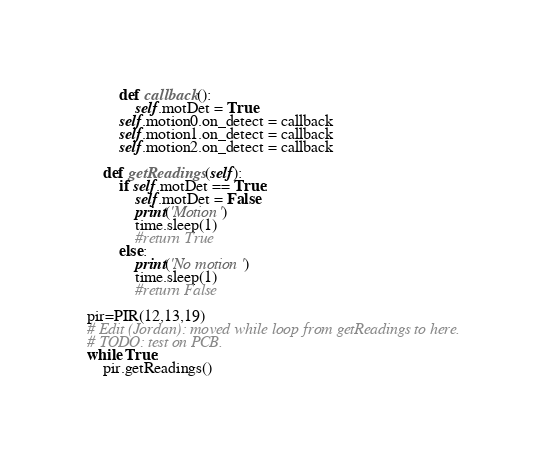<code> <loc_0><loc_0><loc_500><loc_500><_Python_>        def callback():
            self.motDet = True
        self.motion0.on_detect = callback
        self.motion1.on_detect = callback
        self.motion2.on_detect = callback

    def getReadings(self):
        if self.motDet == True:
            self.motDet = False
            print('Motion')
            time.sleep(1)
            #return True
        else:
            print('No motion')
            time.sleep(1)
            #return False

pir=PIR(12,13,19)
# Edit (Jordan): moved while loop from getReadings to here.
# TODO: test on PCB.
while True:
    pir.getReadings()
</code> 